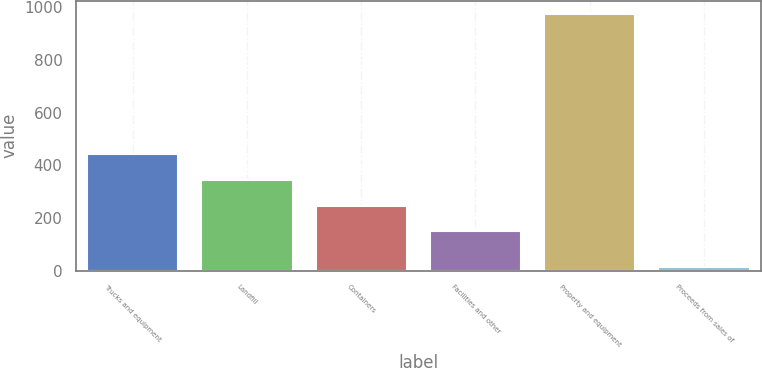Convert chart to OTSL. <chart><loc_0><loc_0><loc_500><loc_500><bar_chart><fcel>Trucks and equipment<fcel>Landfill<fcel>Containers<fcel>Facilities and other<fcel>Property and equipment<fcel>Proceeds from sales of<nl><fcel>442.5<fcel>345<fcel>247.5<fcel>150<fcel>975<fcel>15<nl></chart> 